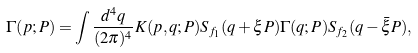Convert formula to latex. <formula><loc_0><loc_0><loc_500><loc_500>\Gamma ( p ; P ) = \int \frac { d ^ { 4 } q } { ( 2 \pi ) ^ { 4 } } K ( p , q ; P ) S _ { f _ { 1 } } ( q + \xi P ) \Gamma ( q ; P ) S _ { f _ { 2 } } ( q - \bar { \xi } P ) ,</formula> 